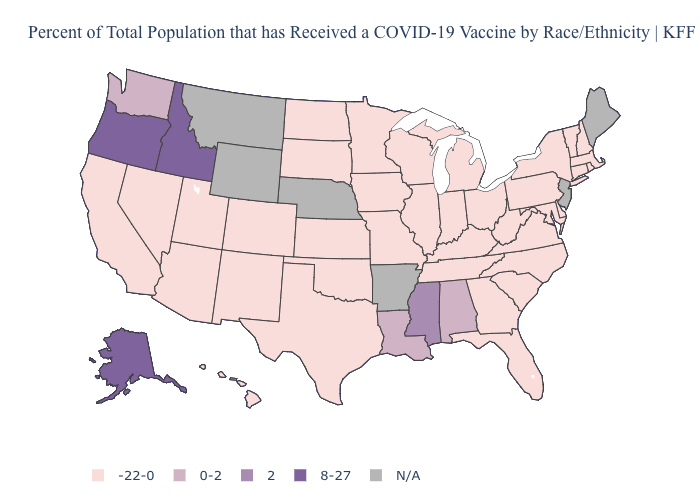What is the value of Rhode Island?
Short answer required. -22-0. Among the states that border Wisconsin , which have the highest value?
Concise answer only. Illinois, Iowa, Michigan, Minnesota. Among the states that border Vermont , which have the highest value?
Be succinct. Massachusetts, New Hampshire, New York. What is the value of Alaska?
Give a very brief answer. 8-27. What is the value of Virginia?
Give a very brief answer. -22-0. Name the states that have a value in the range 2?
Be succinct. Mississippi. Does Alaska have the lowest value in the West?
Give a very brief answer. No. Does the map have missing data?
Concise answer only. Yes. Name the states that have a value in the range 2?
Give a very brief answer. Mississippi. Name the states that have a value in the range -22-0?
Give a very brief answer. Arizona, California, Colorado, Connecticut, Delaware, Florida, Georgia, Hawaii, Illinois, Indiana, Iowa, Kansas, Kentucky, Maryland, Massachusetts, Michigan, Minnesota, Missouri, Nevada, New Hampshire, New Mexico, New York, North Carolina, North Dakota, Ohio, Oklahoma, Pennsylvania, Rhode Island, South Carolina, South Dakota, Tennessee, Texas, Utah, Vermont, Virginia, West Virginia, Wisconsin. What is the value of Illinois?
Write a very short answer. -22-0. What is the value of Virginia?
Quick response, please. -22-0. Name the states that have a value in the range N/A?
Concise answer only. Arkansas, Maine, Montana, Nebraska, New Jersey, Wyoming. 